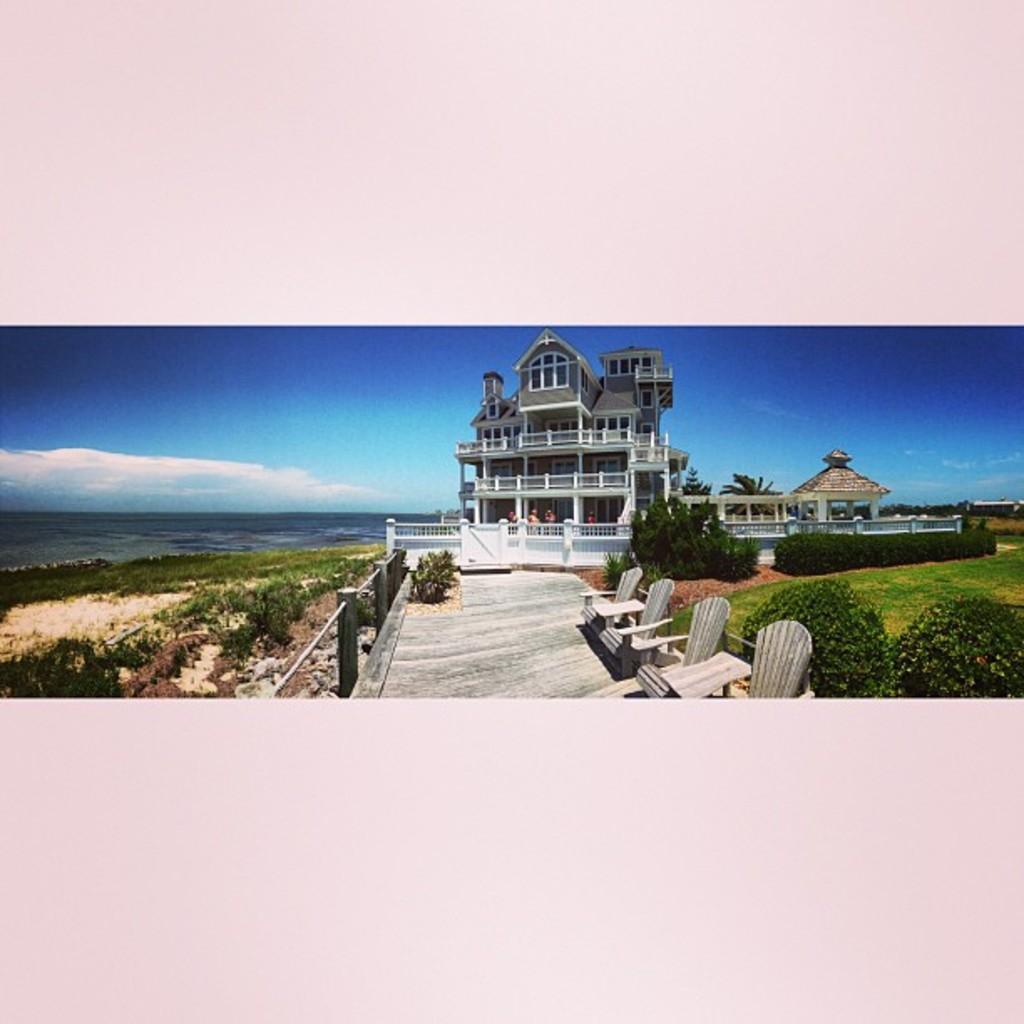Can you describe this image briefly? In the image it looks like a resort, beside the resort there is a beach and in front of the resort there is a garden with many plants and grass, there are few people standing in front of the resort. 